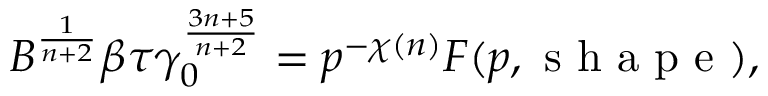Convert formula to latex. <formula><loc_0><loc_0><loc_500><loc_500>B ^ { \frac { 1 } { n + 2 } } \beta \tau \gamma _ { 0 } ^ { \frac { 3 n + 5 } { n + 2 } } = p ^ { - \chi ( n ) } F ( p , s h a p e ) ,</formula> 